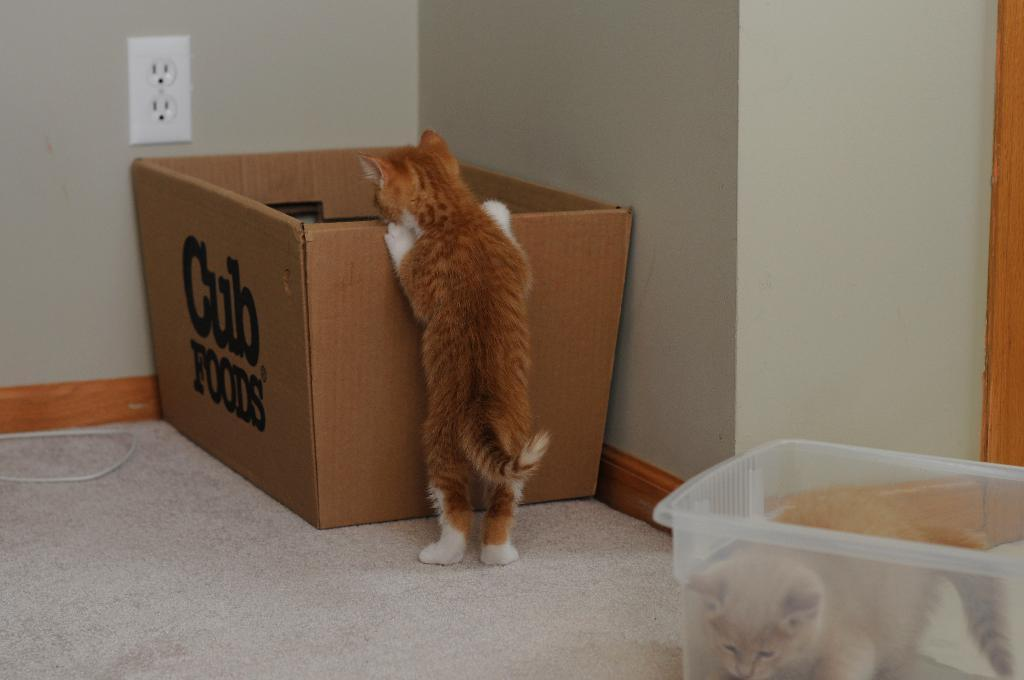<image>
Provide a brief description of the given image. A cat peaking into a box that says cub foods. 